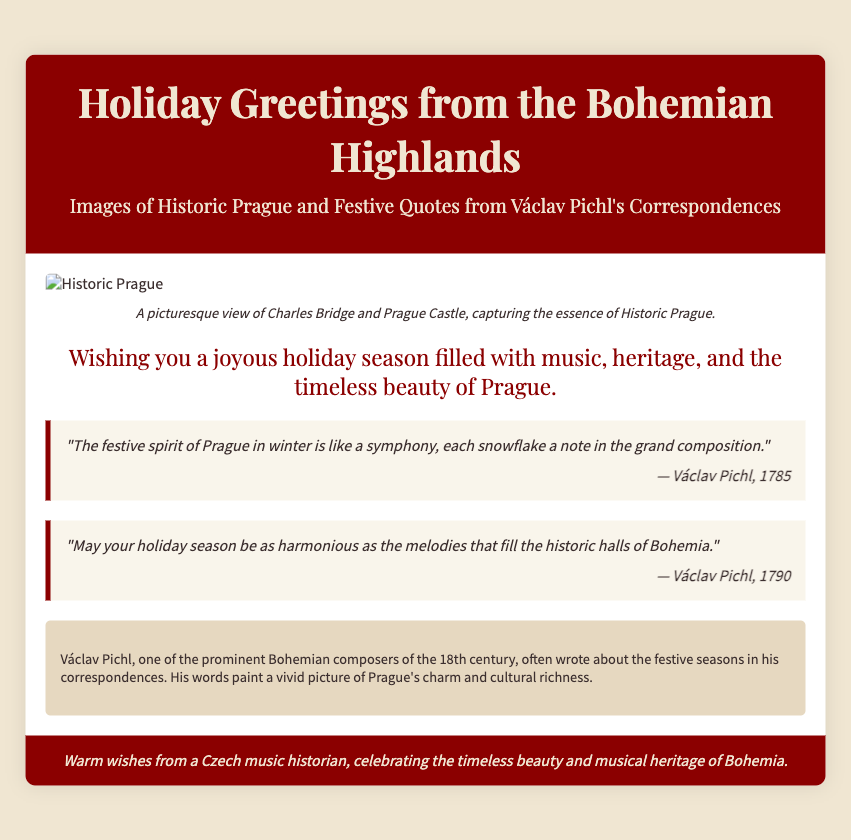What is the title of the card? The title of the card is prominently displayed in the header section of the document.
Answer: Holiday Greetings from the Bohemian Highlands Who is the composer mentioned in the quotes? The composer featured in the festive quotes of the document is noted in the attributions of the quotes.
Answer: Václav Pichl What year was the first quoted message written? The first quote includes a date in its attribution, indicating the year it was composed.
Answer: 1785 What scenic feature is depicted in the cover image? The caption beneath the cover image describes a specific landmark that is visible.
Answer: Charles Bridge How many quotes are included in the card? The document contains a specific number of quotes presented in separate sections.
Answer: Two What is the background color of the body in the card? The background color of the body is defined in the CSS styles included in the document.
Answer: #f0e6d2 Which aspect of Prague is highlighted in the greeting message? The greeting message focuses on a particular quality associated with Prague.
Answer: Music, heritage, and beauty What is the main theme of Václav Pichl's correspondences? The note about Václav Pichl reveals the thematic focus of his correspondences related to the holiday season.
Answer: Festive seasons What colors are used in the card footer? The footer of the card has specific coloring outlined in the document's design elements.
Answer: #8b0000 and #f0e6d2 